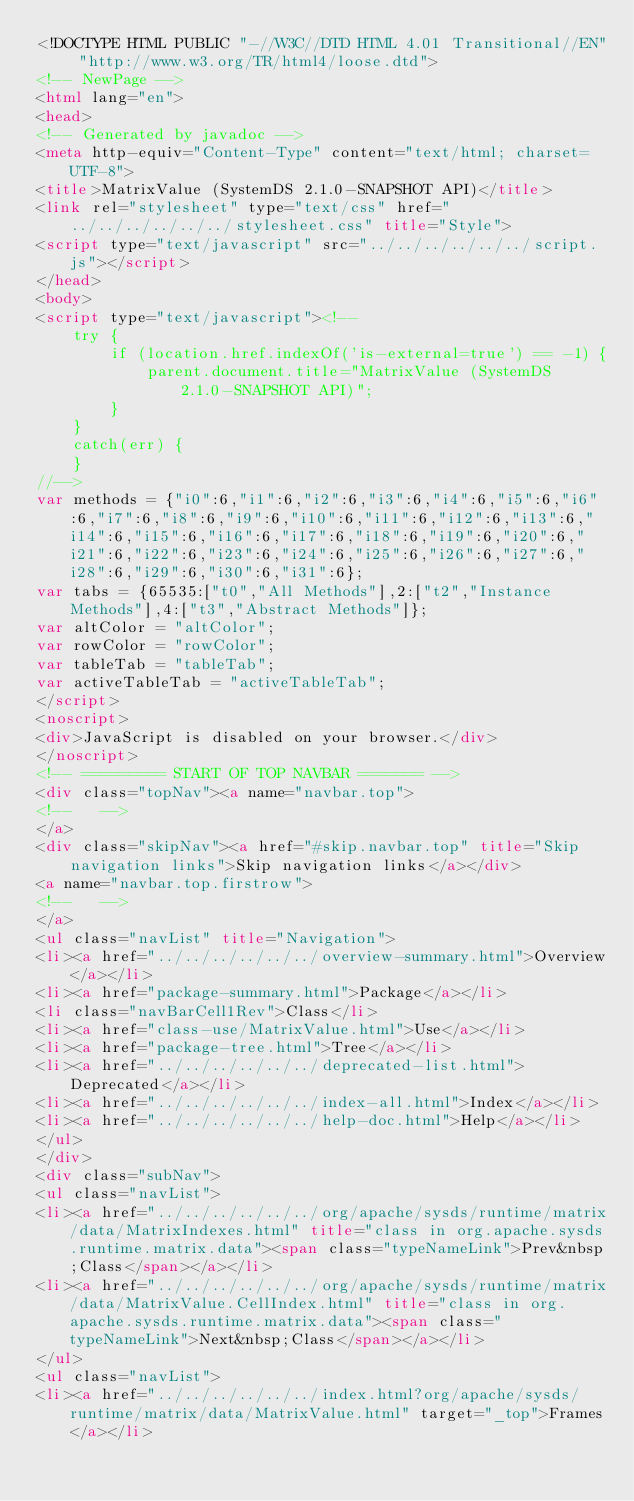Convert code to text. <code><loc_0><loc_0><loc_500><loc_500><_HTML_><!DOCTYPE HTML PUBLIC "-//W3C//DTD HTML 4.01 Transitional//EN" "http://www.w3.org/TR/html4/loose.dtd">
<!-- NewPage -->
<html lang="en">
<head>
<!-- Generated by javadoc -->
<meta http-equiv="Content-Type" content="text/html; charset=UTF-8">
<title>MatrixValue (SystemDS 2.1.0-SNAPSHOT API)</title>
<link rel="stylesheet" type="text/css" href="../../../../../../stylesheet.css" title="Style">
<script type="text/javascript" src="../../../../../../script.js"></script>
</head>
<body>
<script type="text/javascript"><!--
    try {
        if (location.href.indexOf('is-external=true') == -1) {
            parent.document.title="MatrixValue (SystemDS 2.1.0-SNAPSHOT API)";
        }
    }
    catch(err) {
    }
//-->
var methods = {"i0":6,"i1":6,"i2":6,"i3":6,"i4":6,"i5":6,"i6":6,"i7":6,"i8":6,"i9":6,"i10":6,"i11":6,"i12":6,"i13":6,"i14":6,"i15":6,"i16":6,"i17":6,"i18":6,"i19":6,"i20":6,"i21":6,"i22":6,"i23":6,"i24":6,"i25":6,"i26":6,"i27":6,"i28":6,"i29":6,"i30":6,"i31":6};
var tabs = {65535:["t0","All Methods"],2:["t2","Instance Methods"],4:["t3","Abstract Methods"]};
var altColor = "altColor";
var rowColor = "rowColor";
var tableTab = "tableTab";
var activeTableTab = "activeTableTab";
</script>
<noscript>
<div>JavaScript is disabled on your browser.</div>
</noscript>
<!-- ========= START OF TOP NAVBAR ======= -->
<div class="topNav"><a name="navbar.top">
<!--   -->
</a>
<div class="skipNav"><a href="#skip.navbar.top" title="Skip navigation links">Skip navigation links</a></div>
<a name="navbar.top.firstrow">
<!--   -->
</a>
<ul class="navList" title="Navigation">
<li><a href="../../../../../../overview-summary.html">Overview</a></li>
<li><a href="package-summary.html">Package</a></li>
<li class="navBarCell1Rev">Class</li>
<li><a href="class-use/MatrixValue.html">Use</a></li>
<li><a href="package-tree.html">Tree</a></li>
<li><a href="../../../../../../deprecated-list.html">Deprecated</a></li>
<li><a href="../../../../../../index-all.html">Index</a></li>
<li><a href="../../../../../../help-doc.html">Help</a></li>
</ul>
</div>
<div class="subNav">
<ul class="navList">
<li><a href="../../../../../../org/apache/sysds/runtime/matrix/data/MatrixIndexes.html" title="class in org.apache.sysds.runtime.matrix.data"><span class="typeNameLink">Prev&nbsp;Class</span></a></li>
<li><a href="../../../../../../org/apache/sysds/runtime/matrix/data/MatrixValue.CellIndex.html" title="class in org.apache.sysds.runtime.matrix.data"><span class="typeNameLink">Next&nbsp;Class</span></a></li>
</ul>
<ul class="navList">
<li><a href="../../../../../../index.html?org/apache/sysds/runtime/matrix/data/MatrixValue.html" target="_top">Frames</a></li></code> 